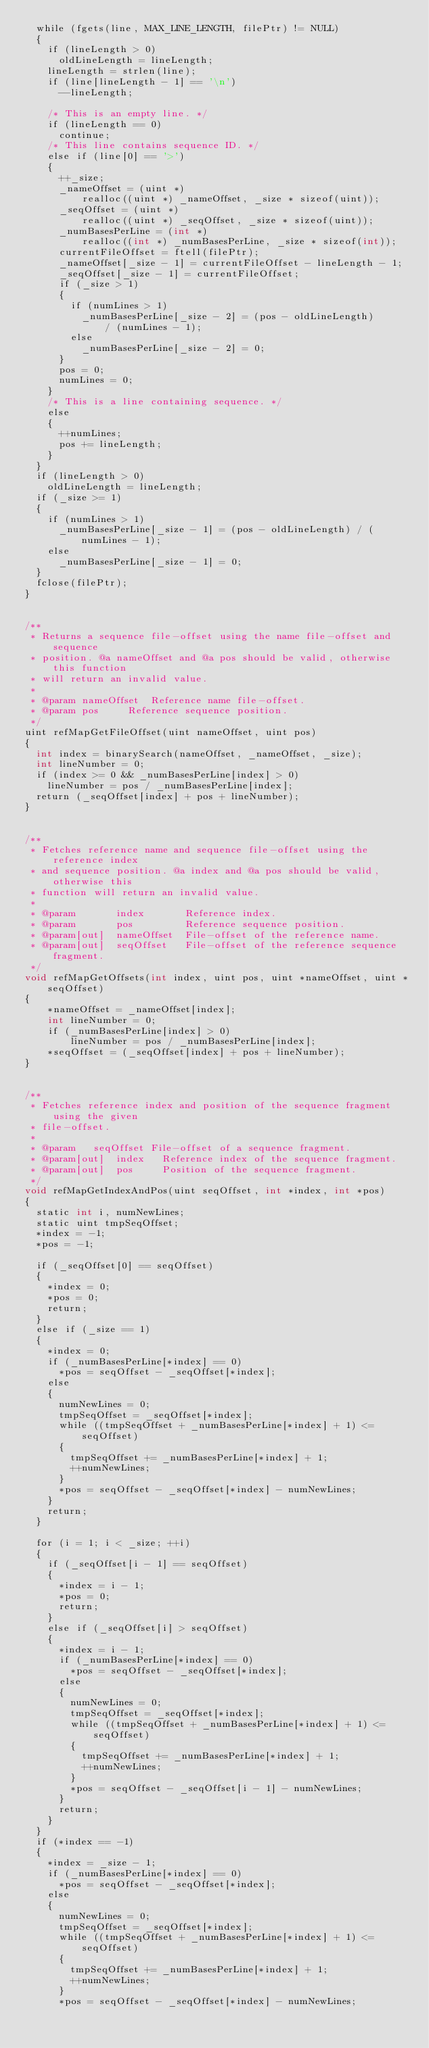<code> <loc_0><loc_0><loc_500><loc_500><_Cuda_>	while (fgets(line, MAX_LINE_LENGTH, filePtr) != NULL)
	{
		if (lineLength > 0)
			oldLineLength = lineLength;
		lineLength = strlen(line);
		if (line[lineLength - 1] == '\n')
			--lineLength;

		/* This is an empty line. */
		if (lineLength == 0)
			continue;
		/* This line contains sequence ID. */
		else if (line[0] == '>')
		{
			++_size;
			_nameOffset = (uint *)
					realloc((uint *) _nameOffset, _size * sizeof(uint));
			_seqOffset = (uint *)
					realloc((uint *) _seqOffset, _size * sizeof(uint));
			_numBasesPerLine = (int *)
					realloc((int *) _numBasesPerLine, _size * sizeof(int));
			currentFileOffset = ftell(filePtr);
			_nameOffset[_size - 1] = currentFileOffset - lineLength - 1;
			_seqOffset[_size - 1] = currentFileOffset;
			if (_size > 1)
			{
				if (numLines > 1)
					_numBasesPerLine[_size - 2] = (pos - oldLineLength)
							/ (numLines - 1);
				else
					_numBasesPerLine[_size - 2] = 0;
			}
			pos = 0;
			numLines = 0;
		}
		/* This is a line containing sequence. */
		else
		{
			++numLines;
			pos += lineLength;
		}
	}
	if (lineLength > 0)
		oldLineLength = lineLength;
	if (_size >= 1)
	{
		if (numLines > 1)
			_numBasesPerLine[_size - 1] = (pos - oldLineLength) / (numLines - 1);
		else
			_numBasesPerLine[_size - 1] = 0;
	}
	fclose(filePtr);
}


/**
 * Returns a sequence file-offset using the name file-offset and sequence
 * position. @a nameOffset and @a pos should be valid, otherwise this function
 * will return an invalid value.
 *
 * @param	nameOffset	Reference name file-offset.
 * @param	pos			Reference sequence position.
 */
uint refMapGetFileOffset(uint nameOffset, uint pos)
{
	int index = binarySearch(nameOffset, _nameOffset, _size);
	int lineNumber = 0;
	if (index >= 0 && _numBasesPerLine[index] > 0)
		lineNumber = pos / _numBasesPerLine[index];
	return (_seqOffset[index] + pos + lineNumber);
}


/**
 * Fetches reference name and sequence file-offset using the reference index
 * and sequence position. @a index and @a pos should be valid, otherwise this
 * function will return an invalid value.
 *
 * @param       index       Reference index.
 * @param       pos         Reference sequence position.
 * @param[out]  nameOffset  File-offset of the reference name.
 * @param[out]  seqOffset   File-offset of the reference sequence fragment.
 */
void refMapGetOffsets(int index, uint pos, uint *nameOffset, uint *seqOffset)
{
    *nameOffset = _nameOffset[index];
    int lineNumber = 0;
    if (_numBasesPerLine[index] > 0)
        lineNumber = pos / _numBasesPerLine[index];
    *seqOffset = (_seqOffset[index] + pos + lineNumber);
}


/**
 * Fetches reference index and position of the sequence fragment using the given
 * file-offset.
 *
 * @param		seqOffset	File-offset of a sequence fragment.
 * @param[out] 	index		Reference index of the sequence fragment.
 * @param[out]	pos			Position of the sequence fragment.
 */
void refMapGetIndexAndPos(uint seqOffset, int *index, int *pos)
{
	static int i, numNewLines;
	static uint tmpSeqOffset;
	*index = -1;
	*pos = -1;

	if (_seqOffset[0] == seqOffset)
	{
		*index = 0;
		*pos = 0;
		return;
	}
	else if (_size == 1)
	{
		*index = 0;
		if (_numBasesPerLine[*index] == 0)
			*pos = seqOffset - _seqOffset[*index];
		else
		{
			numNewLines = 0;
			tmpSeqOffset = _seqOffset[*index];
			while ((tmpSeqOffset + _numBasesPerLine[*index] + 1) <= seqOffset)
			{
				tmpSeqOffset += _numBasesPerLine[*index] + 1;
				++numNewLines;
			}
			*pos = seqOffset - _seqOffset[*index] - numNewLines;
		}
		return;
	}

	for (i = 1; i < _size; ++i)
	{
		if (_seqOffset[i - 1] == seqOffset)
		{
			*index = i - 1;
			*pos = 0;
			return;
		}
		else if (_seqOffset[i] > seqOffset)
		{
			*index = i - 1;
			if (_numBasesPerLine[*index] == 0)
				*pos = seqOffset - _seqOffset[*index];
			else
			{
				numNewLines = 0;
				tmpSeqOffset = _seqOffset[*index];
				while ((tmpSeqOffset + _numBasesPerLine[*index] + 1) <= seqOffset)
				{
					tmpSeqOffset += _numBasesPerLine[*index] + 1;
					++numNewLines;
				}
				*pos = seqOffset - _seqOffset[i - 1] - numNewLines;
			}
			return;
		}
	}
	if (*index == -1)
	{
		*index = _size - 1;
		if (_numBasesPerLine[*index] == 0)
			*pos = seqOffset - _seqOffset[*index];
		else
		{
			numNewLines = 0;
			tmpSeqOffset = _seqOffset[*index];
			while ((tmpSeqOffset + _numBasesPerLine[*index] + 1) <= seqOffset)
			{
				tmpSeqOffset += _numBasesPerLine[*index] + 1;
				++numNewLines;
			}
			*pos = seqOffset - _seqOffset[*index] - numNewLines;</code> 